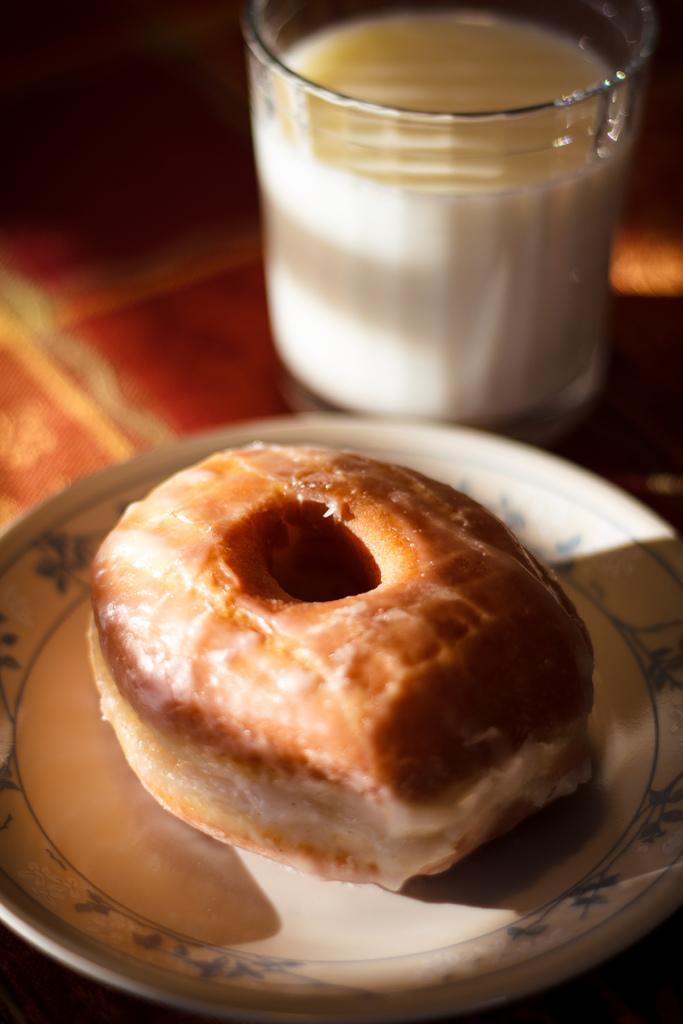Could you give a brief overview of what you see in this image? In the image there is a donut on a plate with milk glass in front of it on the floor. 